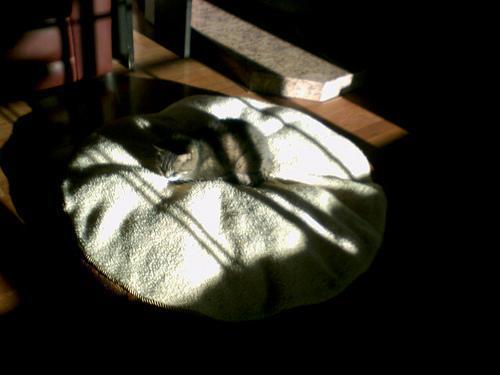How many men are shirtless?
Give a very brief answer. 0. 